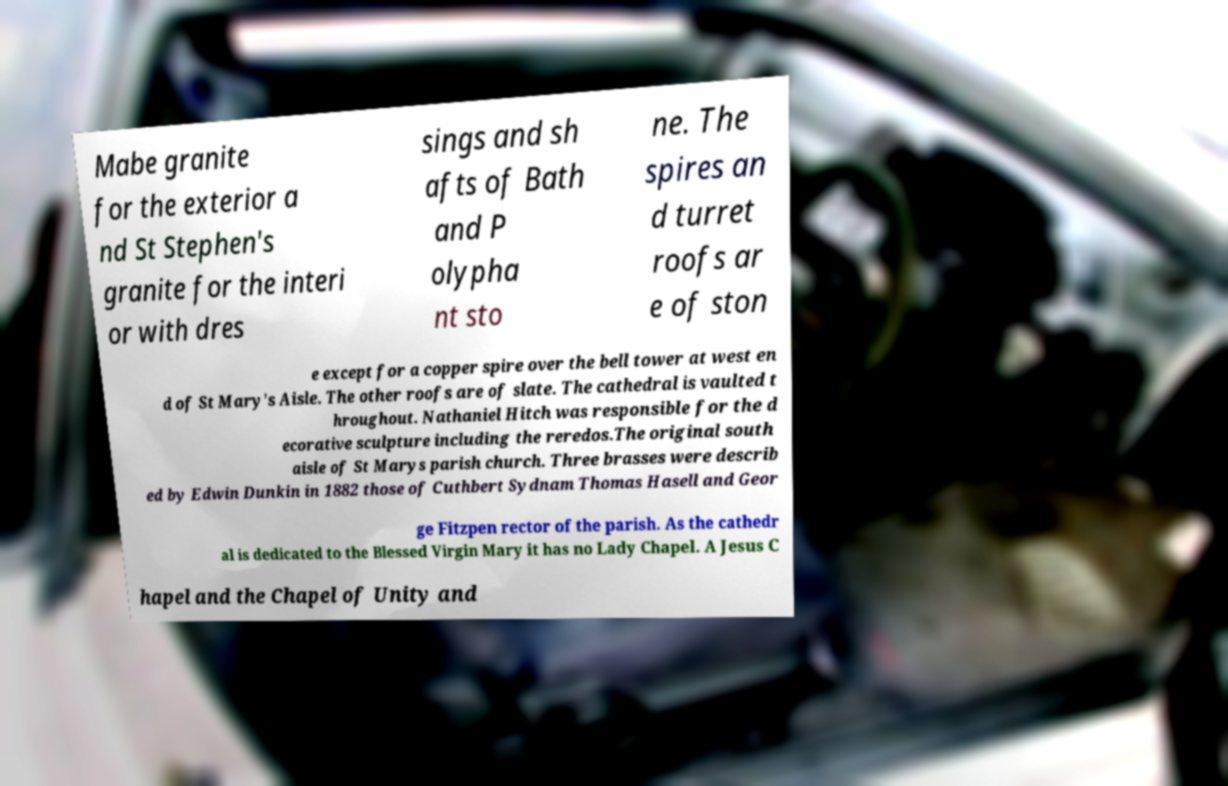Can you accurately transcribe the text from the provided image for me? Mabe granite for the exterior a nd St Stephen's granite for the interi or with dres sings and sh afts of Bath and P olypha nt sto ne. The spires an d turret roofs ar e of ston e except for a copper spire over the bell tower at west en d of St Mary's Aisle. The other roofs are of slate. The cathedral is vaulted t hroughout. Nathaniel Hitch was responsible for the d ecorative sculpture including the reredos.The original south aisle of St Marys parish church. Three brasses were describ ed by Edwin Dunkin in 1882 those of Cuthbert Sydnam Thomas Hasell and Geor ge Fitzpen rector of the parish. As the cathedr al is dedicated to the Blessed Virgin Mary it has no Lady Chapel. A Jesus C hapel and the Chapel of Unity and 